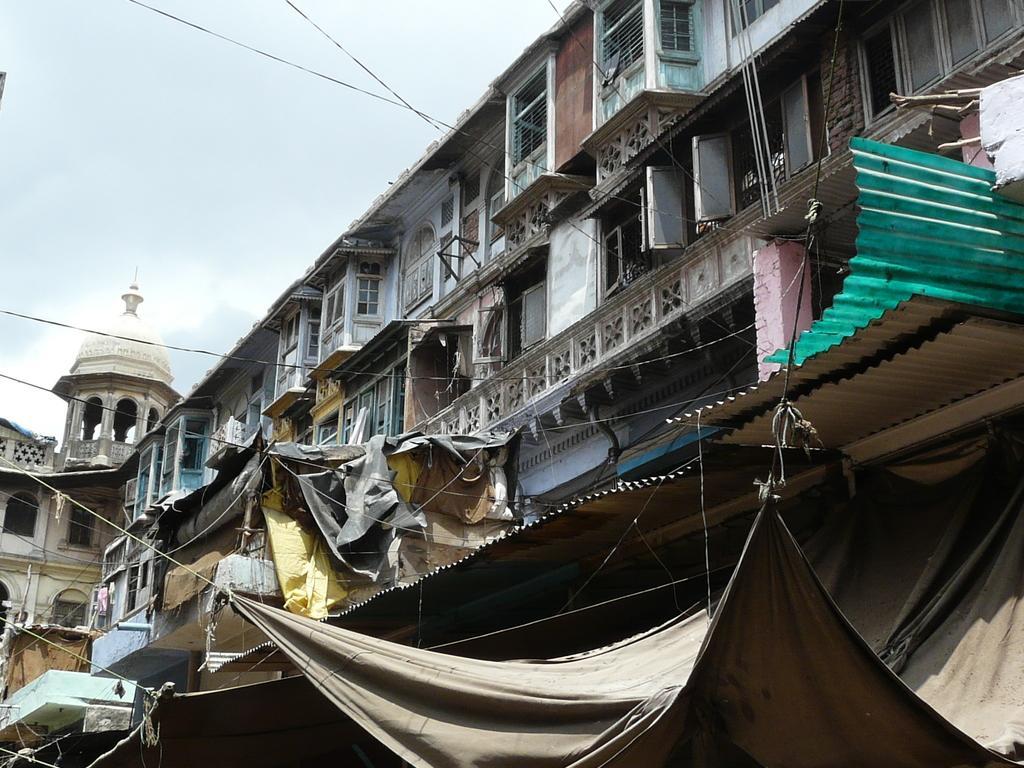Can you describe this image briefly? In this image there is a building for that building there are windows, in the bottom right there is tent. 